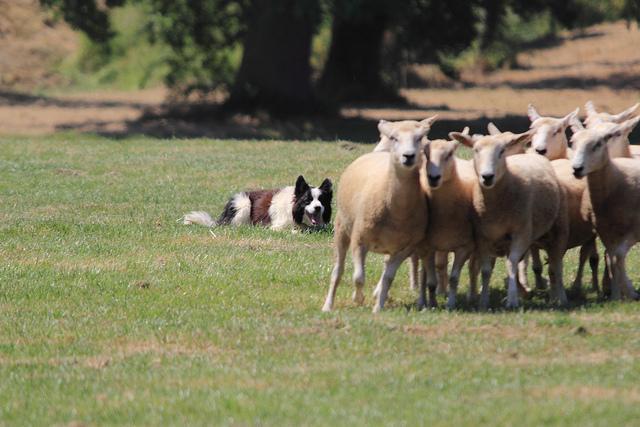How many sheeps are this?
Give a very brief answer. 6. How many sheep can you see?
Give a very brief answer. 5. How many beds are there?
Give a very brief answer. 0. 